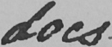Please transcribe the handwritten text in this image. does 